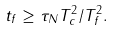Convert formula to latex. <formula><loc_0><loc_0><loc_500><loc_500>t _ { f } \geq \tau _ { N } T _ { c } ^ { 2 } / T _ { f } ^ { 2 } .</formula> 